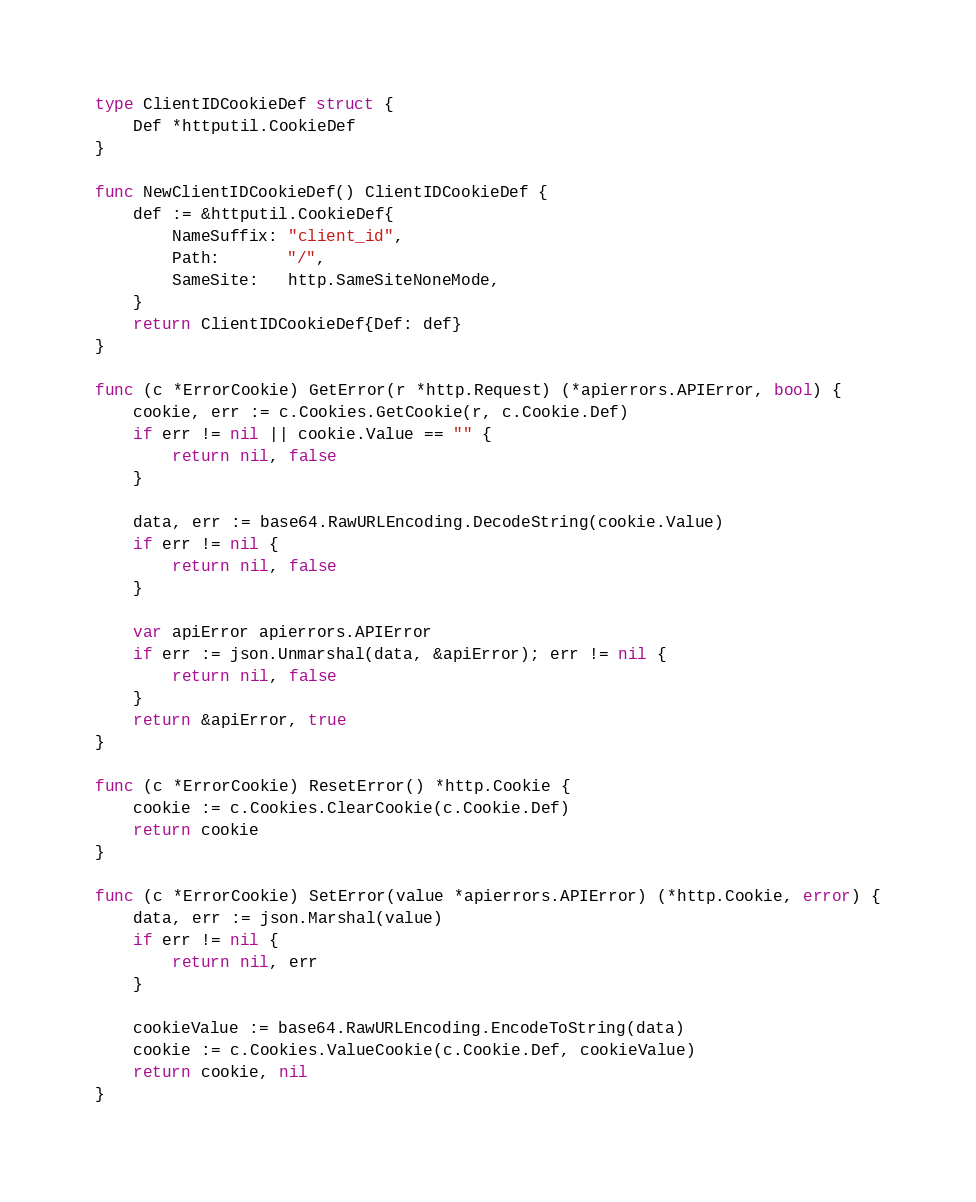<code> <loc_0><loc_0><loc_500><loc_500><_Go_>type ClientIDCookieDef struct {
	Def *httputil.CookieDef
}

func NewClientIDCookieDef() ClientIDCookieDef {
	def := &httputil.CookieDef{
		NameSuffix: "client_id",
		Path:       "/",
		SameSite:   http.SameSiteNoneMode,
	}
	return ClientIDCookieDef{Def: def}
}

func (c *ErrorCookie) GetError(r *http.Request) (*apierrors.APIError, bool) {
	cookie, err := c.Cookies.GetCookie(r, c.Cookie.Def)
	if err != nil || cookie.Value == "" {
		return nil, false
	}

	data, err := base64.RawURLEncoding.DecodeString(cookie.Value)
	if err != nil {
		return nil, false
	}

	var apiError apierrors.APIError
	if err := json.Unmarshal(data, &apiError); err != nil {
		return nil, false
	}
	return &apiError, true
}

func (c *ErrorCookie) ResetError() *http.Cookie {
	cookie := c.Cookies.ClearCookie(c.Cookie.Def)
	return cookie
}

func (c *ErrorCookie) SetError(value *apierrors.APIError) (*http.Cookie, error) {
	data, err := json.Marshal(value)
	if err != nil {
		return nil, err
	}

	cookieValue := base64.RawURLEncoding.EncodeToString(data)
	cookie := c.Cookies.ValueCookie(c.Cookie.Def, cookieValue)
	return cookie, nil
}
</code> 